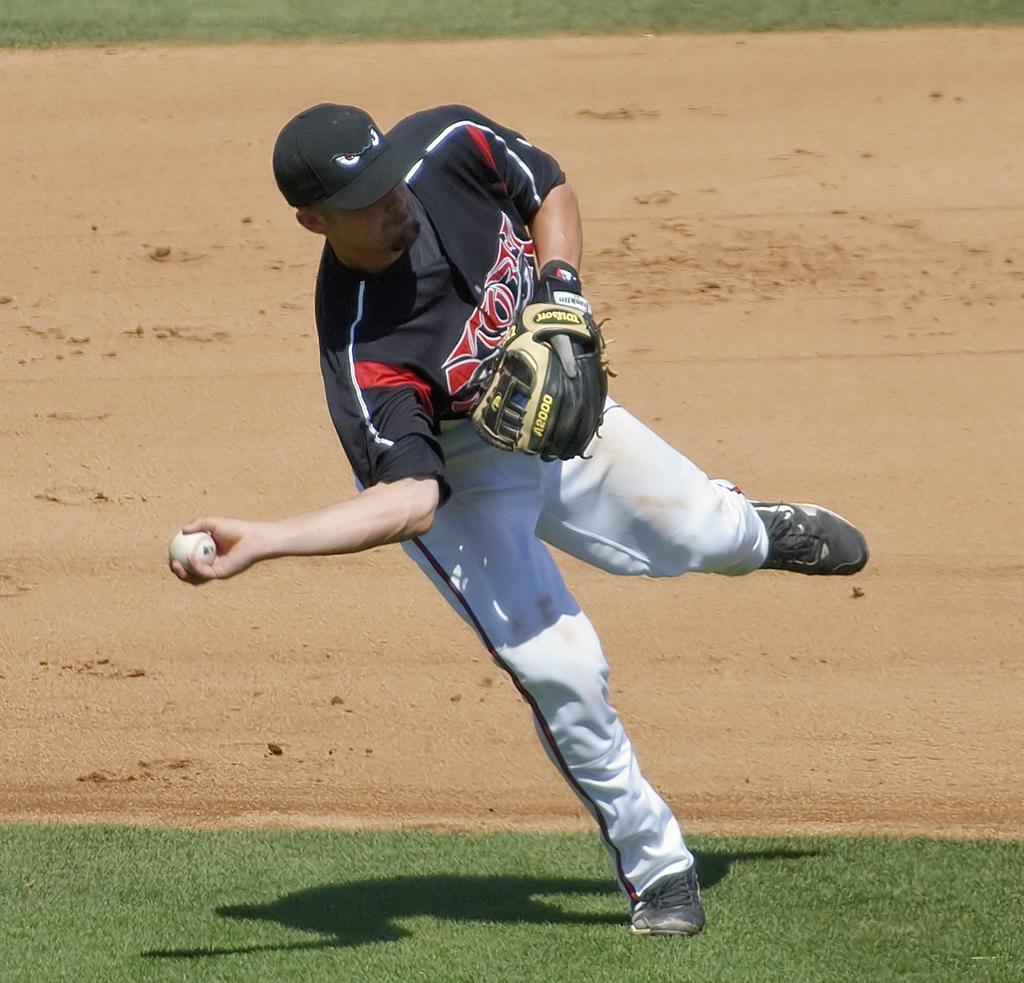Can you describe this image briefly? In the middle of the image, there is a person in black color t-shirt, wearing a black color cap and a glove, holding a white color ball with one hand and running on the ground, on which there is grass. In the ground, there is dry land and there's grass on the ground. 